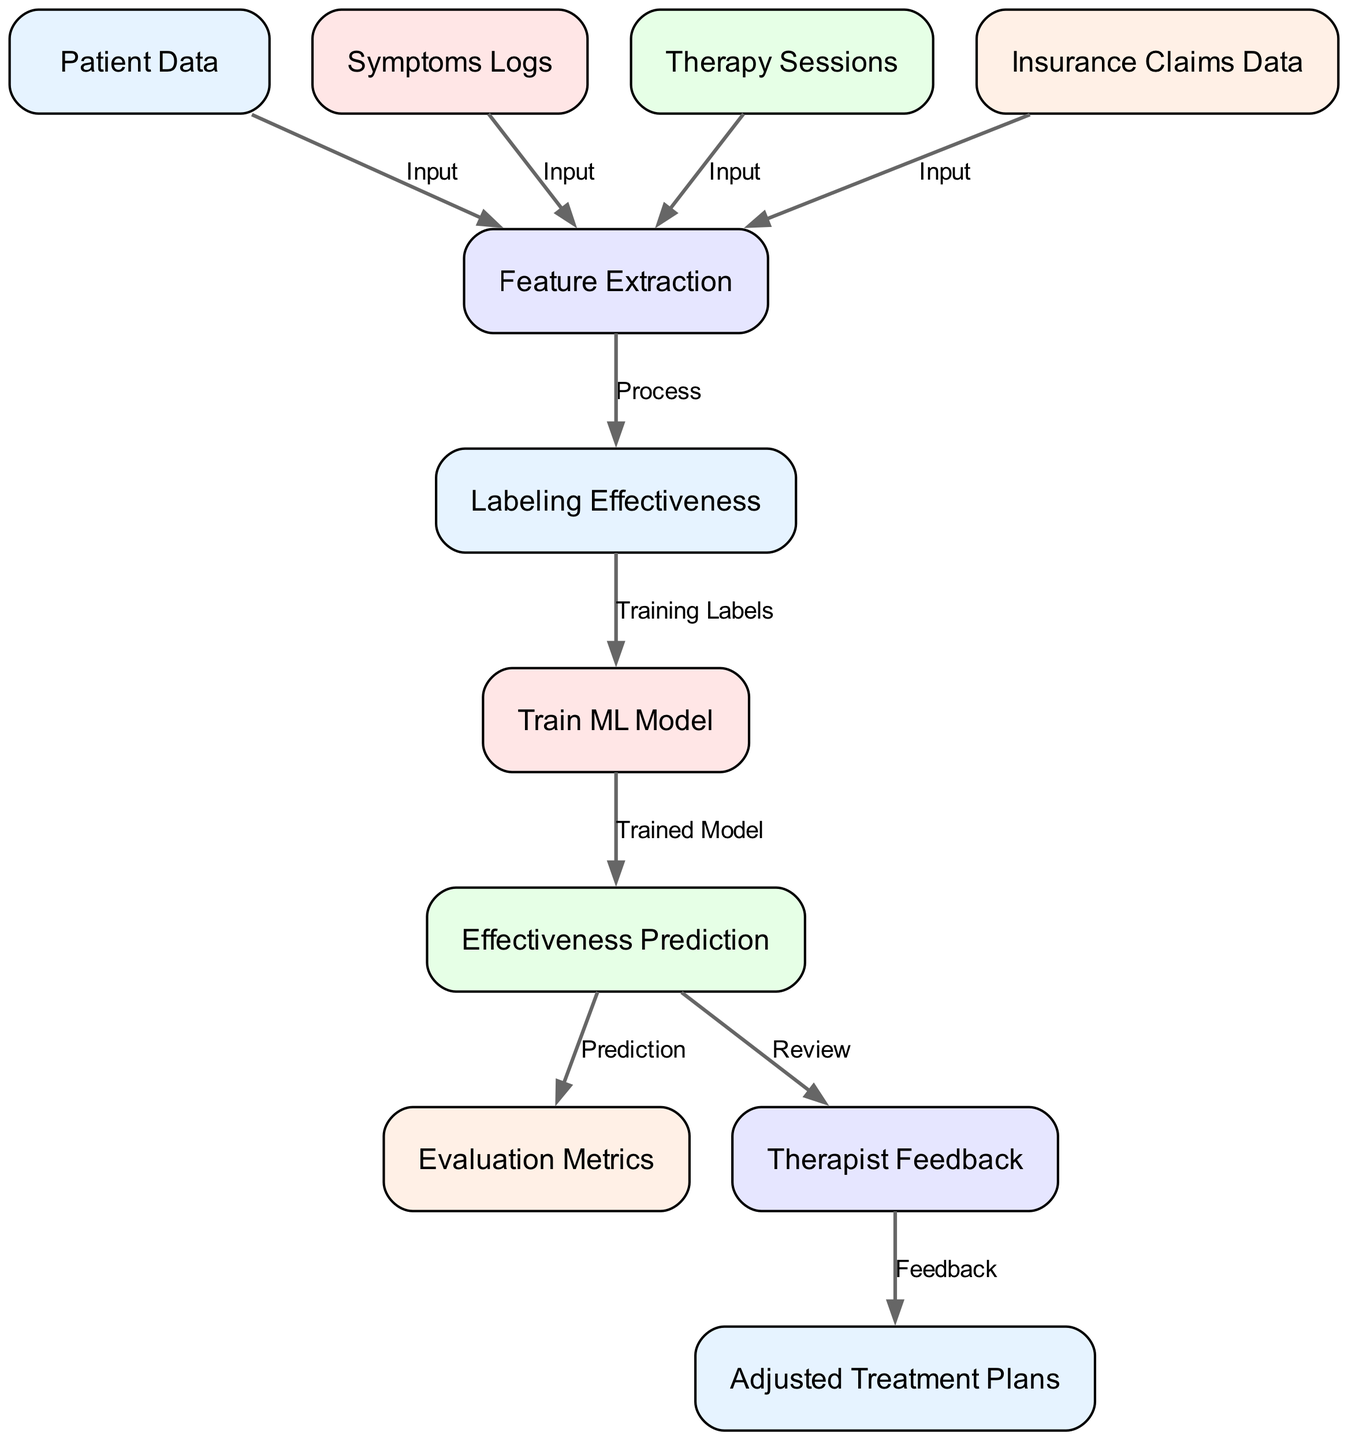What is the total number of nodes in the diagram? The diagram contains 11 nodes, each representing different components of the automated classification of therapy effectiveness process.
Answer: 11 What type of data is labeled at the "Insurance Claims Data" node? The "Insurance Claims Data" node contains details of insurance claims filed by patients, which is used as input for feature extraction.
Answer: Details of insurance claims Which node directly receives input from "Symptoms Logs"? "Feature Extraction" directly receives input from the "Symptoms Logs" node, as indicated by the connecting edge in the diagram.
Answer: Feature Extraction What process is indicated between "Feature Extraction" and "Labeling Effectiveness"? The edge between these two nodes indicates the process of labeling therapy sessions based on the outcomes obtained from the extracted features.
Answer: Process What is used to train the ML model? The "Labeling Effectiveness" node provides training labels for the model, which allows it to learn from labeled features for predicting therapy effectiveness.
Answer: Labeling Effectiveness How many edges are there in the diagram? There are 10 edges in the diagram, showing connections and processes between various nodes contributing to the machine learning model.
Answer: 10 What type of feedback is collected in the "Therapist Feedback" node? "Therapist Feedback" collects reviews and feedback from therapists regarding the predictions made by the effectiveness prediction node.
Answer: Review and feedback How does the "Effectiveness Prediction" node connect with "Evaluation Metrics"? The "Effectiveness Prediction" node makes a prediction that is subsequently evaluated using various metrics, thus generating connections to the "Evaluation Metrics" node.
Answer: Prediction Which node is responsible for adjusting treatment plans? The "Adjusted Treatment Plans" node is responsible for creating revised treatment plans based on the predictions made by the model and feedback received from the therapists.
Answer: Adjusted Treatment Plans 